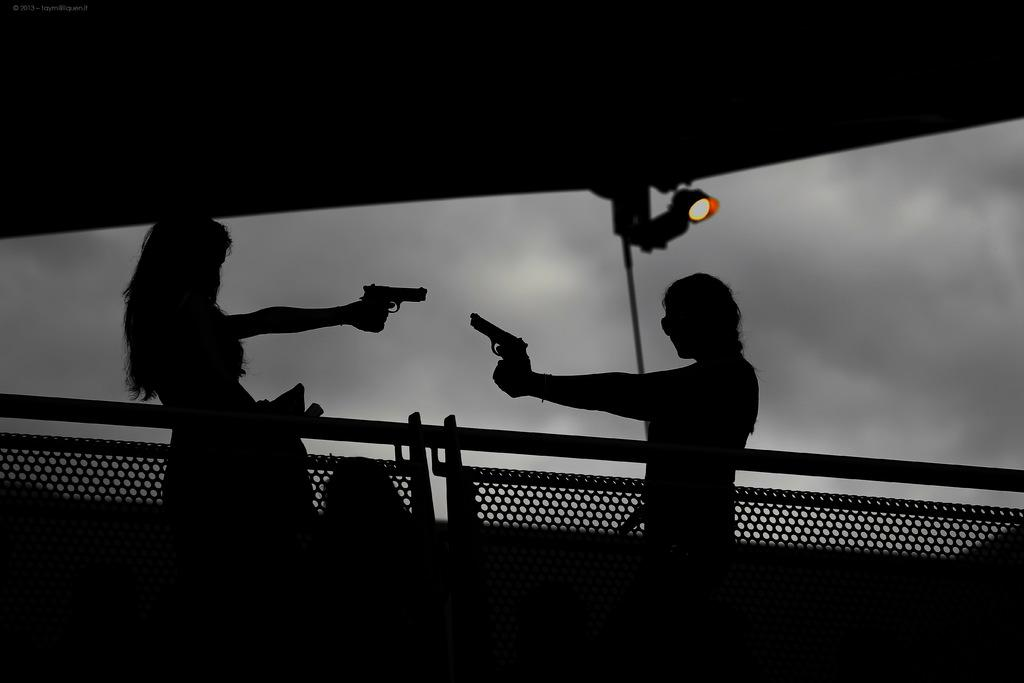What is the color scheme of the image? The image is in black and white. How many people are in the image? There are two people in the image. What are the people doing in the image? The people are standing and holding guns. What is located behind the people in the image? There is a barrier fence behind the people. Can you describe the lighting in the image? There is light visible in the image. What is the condition of the sky in the background? The sky is cloudy in the background. What type of locket is the spy wearing in the image? There is no spy or locket present in the image. Can you tell me how many chess pieces are on the table in the image? There is no table or chess pieces present in the image. 